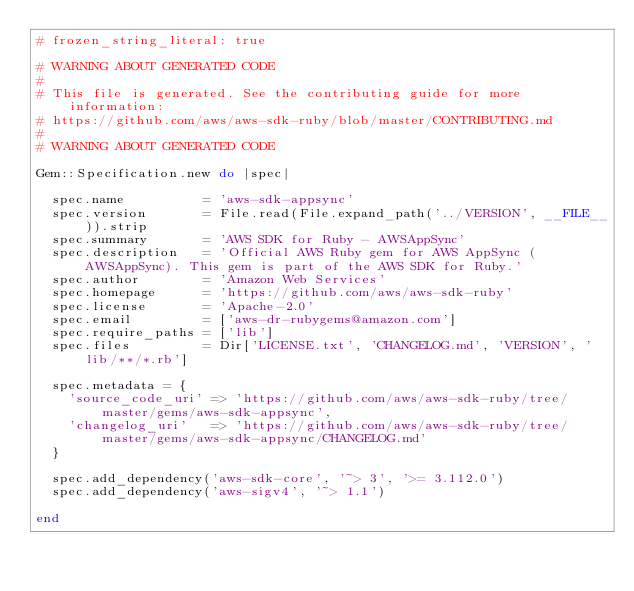Convert code to text. <code><loc_0><loc_0><loc_500><loc_500><_Ruby_># frozen_string_literal: true

# WARNING ABOUT GENERATED CODE
#
# This file is generated. See the contributing guide for more information:
# https://github.com/aws/aws-sdk-ruby/blob/master/CONTRIBUTING.md
#
# WARNING ABOUT GENERATED CODE

Gem::Specification.new do |spec|

  spec.name          = 'aws-sdk-appsync'
  spec.version       = File.read(File.expand_path('../VERSION', __FILE__)).strip
  spec.summary       = 'AWS SDK for Ruby - AWSAppSync'
  spec.description   = 'Official AWS Ruby gem for AWS AppSync (AWSAppSync). This gem is part of the AWS SDK for Ruby.'
  spec.author        = 'Amazon Web Services'
  spec.homepage      = 'https://github.com/aws/aws-sdk-ruby'
  spec.license       = 'Apache-2.0'
  spec.email         = ['aws-dr-rubygems@amazon.com']
  spec.require_paths = ['lib']
  spec.files         = Dir['LICENSE.txt', 'CHANGELOG.md', 'VERSION', 'lib/**/*.rb']

  spec.metadata = {
    'source_code_uri' => 'https://github.com/aws/aws-sdk-ruby/tree/master/gems/aws-sdk-appsync',
    'changelog_uri'   => 'https://github.com/aws/aws-sdk-ruby/tree/master/gems/aws-sdk-appsync/CHANGELOG.md'
  }

  spec.add_dependency('aws-sdk-core', '~> 3', '>= 3.112.0')
  spec.add_dependency('aws-sigv4', '~> 1.1')

end
</code> 